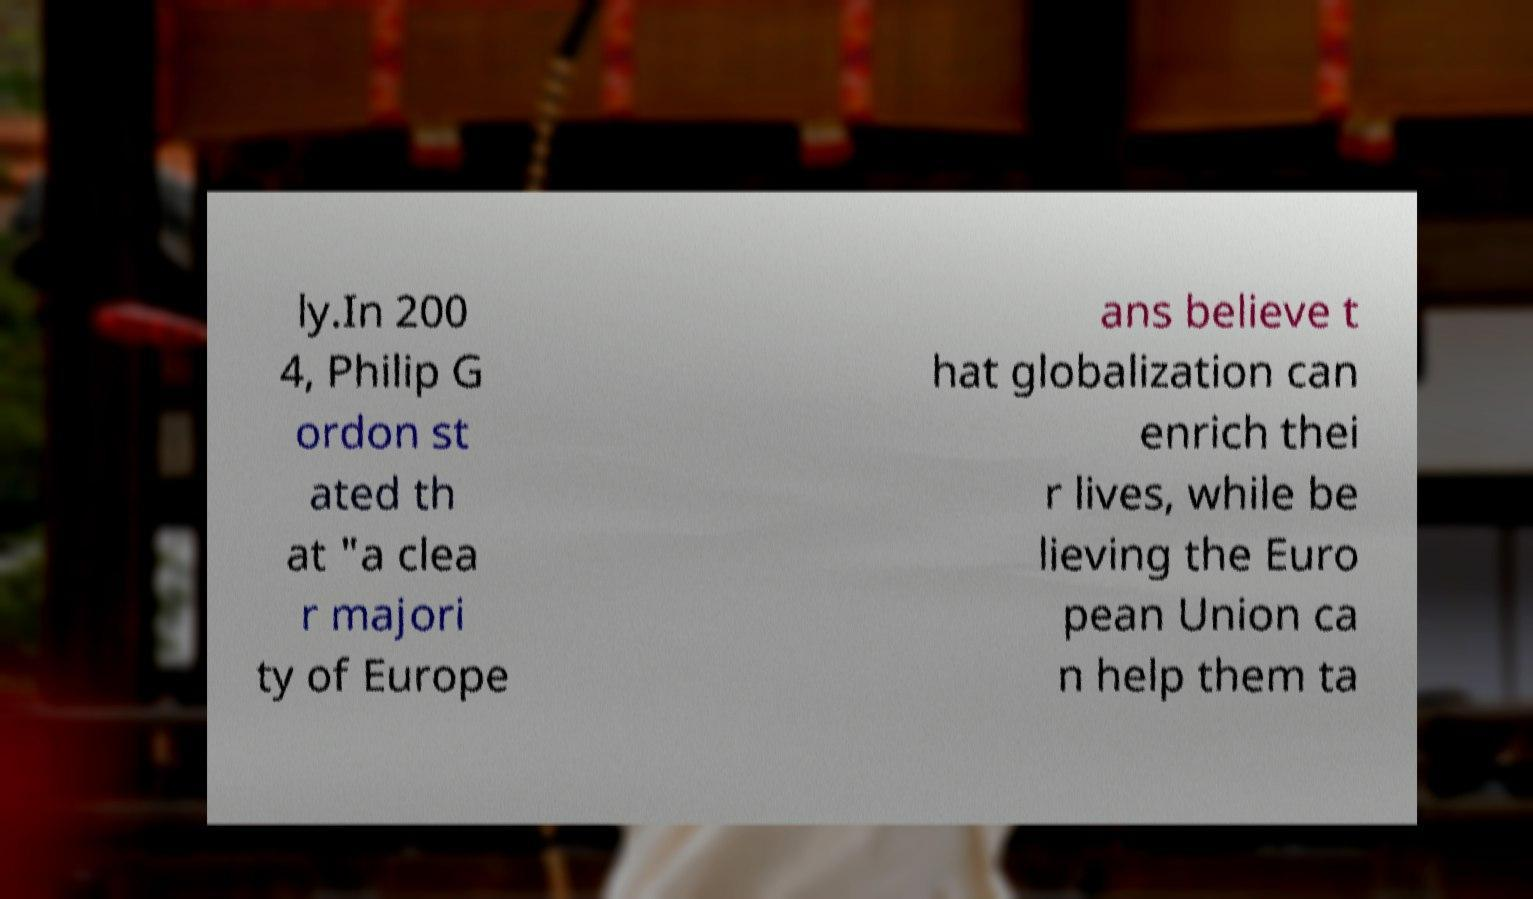Could you extract and type out the text from this image? ly.In 200 4, Philip G ordon st ated th at "a clea r majori ty of Europe ans believe t hat globalization can enrich thei r lives, while be lieving the Euro pean Union ca n help them ta 